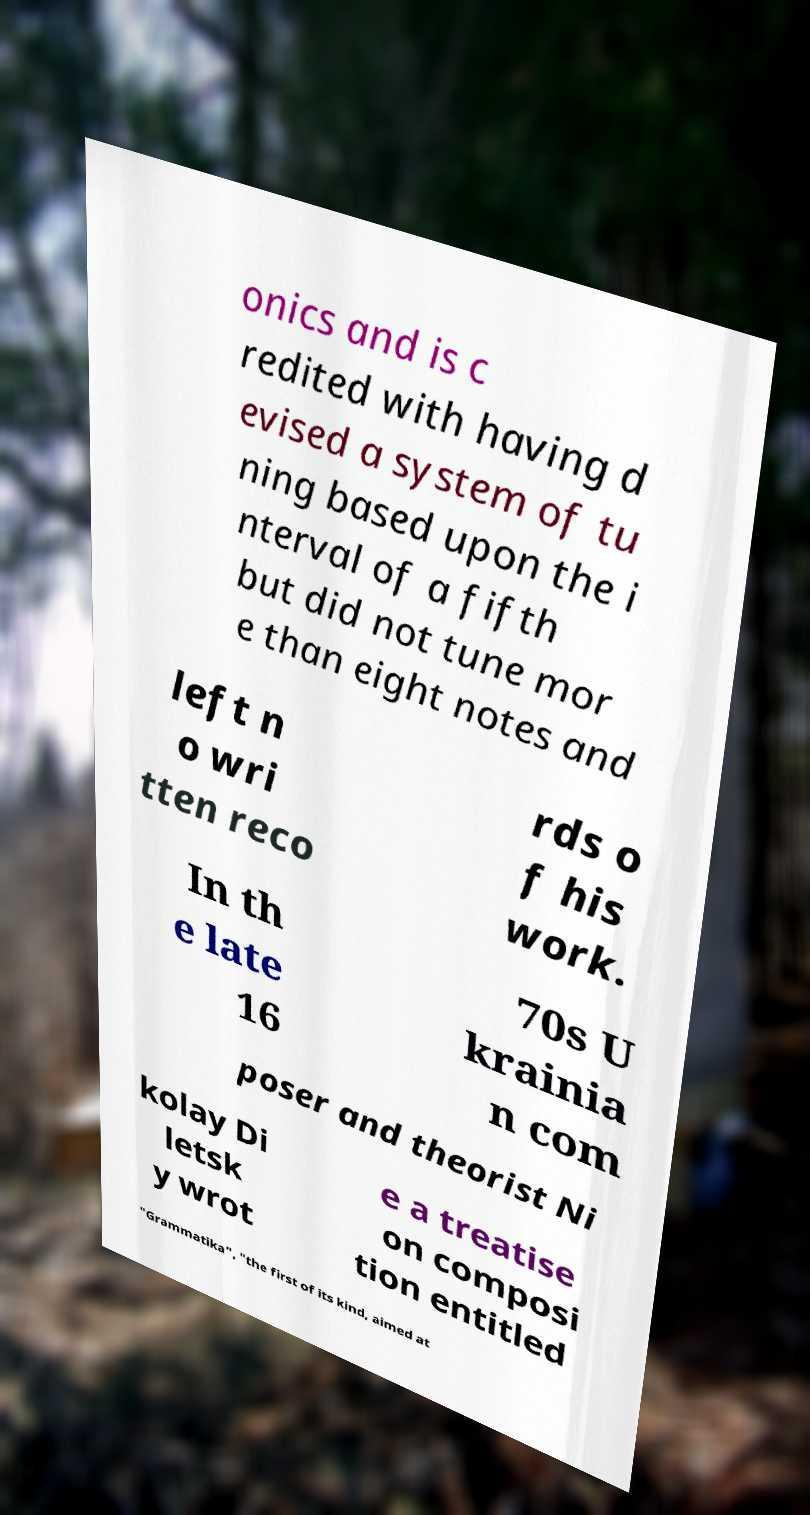Please read and relay the text visible in this image. What does it say? onics and is c redited with having d evised a system of tu ning based upon the i nterval of a fifth but did not tune mor e than eight notes and left n o wri tten reco rds o f his work. In th e late 16 70s U krainia n com poser and theorist Ni kolay Di letsk y wrot e a treatise on composi tion entitled "Grammatika", "the first of its kind, aimed at 